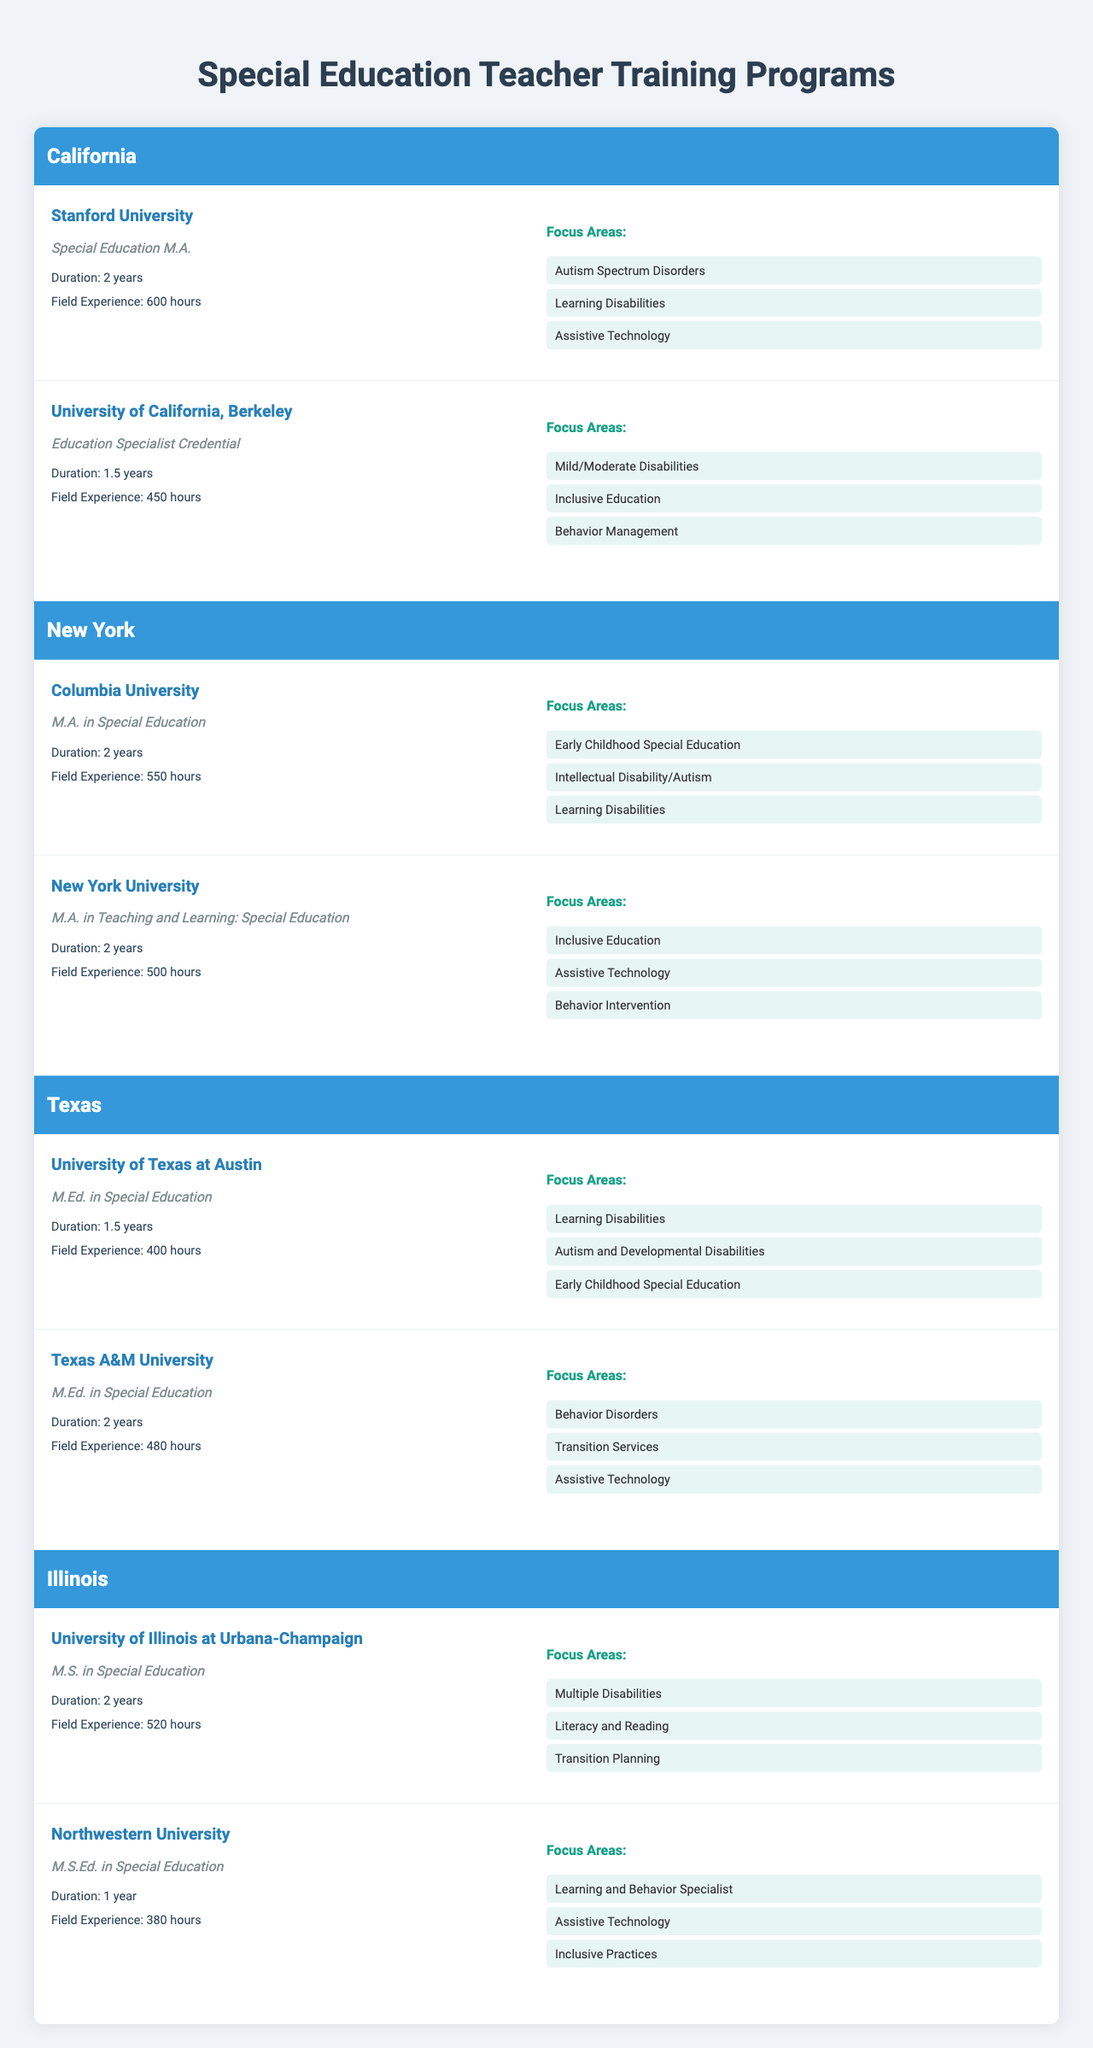What programs are offered in California? In the table, California lists two programs: the Special Education M.A. from Stanford University and the Education Specialist Credential from the University of California, Berkeley.
Answer: Special Education M.A. and Education Specialist Credential Which university offers a program with the longest duration in Texas? In Texas, the University of Texas at Austin and Texas A&M University both offer programs, but only Texas A&M offers a M.Ed. in Special Education with a duration of 2 years.
Answer: Texas A&M University Count the total field experience hours required for the programs in New York. The total field experience hours for New York are calculated by adding the hours: 550 (Columbia University) + 500 (New York University) = 1050.
Answer: 1050 hours Do any programs in Illinois focus on Learning Disabilities? The University of Illinois at Urbana-Champaign offers a program that focuses on Multiple Disabilities which may include Learning Disabilities, while Northwestern University does focus on Learning and Behavior Specialist, suggesting a connection to Learning Disabilities. Therefore, yes, programs focus on Learning Disabilities.
Answer: Yes What is the average duration of programs in California? There are two program durations in California: 2 years and 1.5 years. To find the average: (2 + 1.5) / 2 = 1.75 years.
Answer: 1.75 years Which state has the highest number of field experience hours required for its programs? Comparing the field experience hours among the states, California requires 600 and 450 hours, New York requires 550 and 500 hours, Texas requires 400 and 480 hours, and Illinois requires 520 and 380 hours. California has the highest at 600 hours.
Answer: California What is the maximum field experience hours requirement among all programs? The highest number of field experience hours from all states is 600 hours from Stanford University in California.
Answer: 600 hours Does the University of Texas at Austin focus on Assistive Technology in their program? The University of Texas at Austin's program focuses on Learning Disabilities and related areas, but Assistive Technology is not listed as a focus area specifically for their program.
Answer: No Identify the states that offer a 1-year specialization program. In the table, Illinois is the only state that has a program with a duration of just 1 year at Northwestern University.
Answer: Illinois How does the field experience hours compare between the two programs offered in Texas? The two programs in Texas require 400 hours (University of Texas at Austin) and 480 hours (Texas A&M University). The difference is 480 - 400 = 80 hours, meaning Texas A&M requires more field experience.
Answer: 80 hours difference 